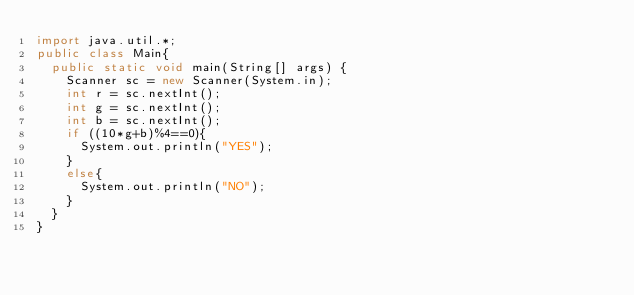<code> <loc_0><loc_0><loc_500><loc_500><_Java_>import java.util.*;
public class Main{
  public static void main(String[] args) {
    Scanner sc = new Scanner(System.in);
    int r = sc.nextInt();
    int g = sc.nextInt();
    int b = sc.nextInt();
    if ((10*g+b)%4==0){
      System.out.println("YES");
    }
    else{
      System.out.println("NO");
    }
  }
}</code> 